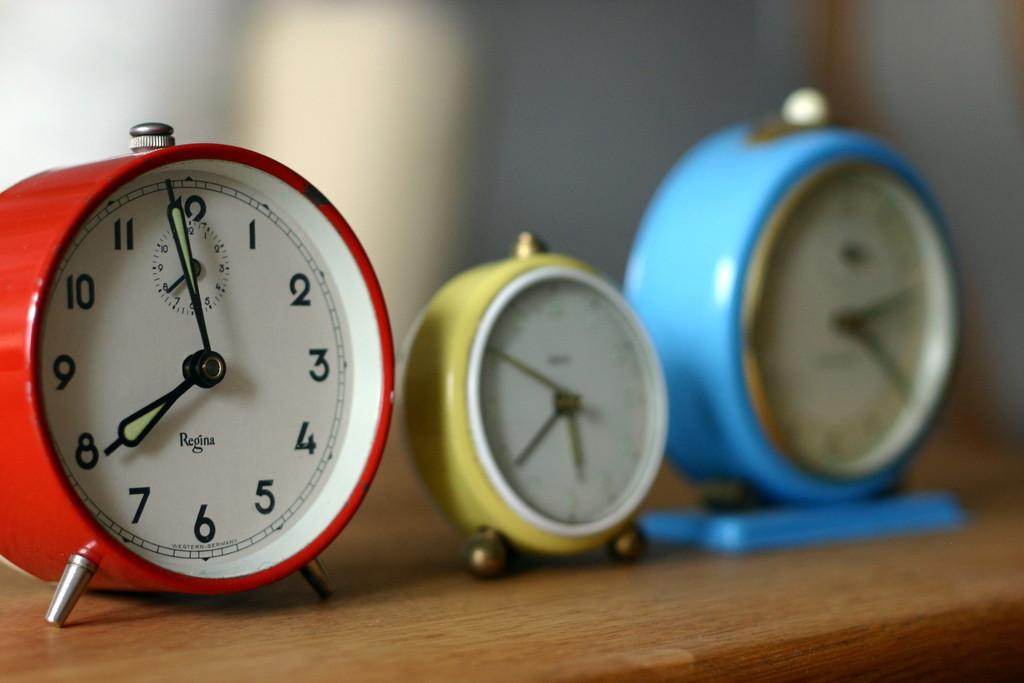What time does the red clock say?
Your response must be concise. 7:59. Is the red clock a regina clock?
Make the answer very short. Yes. 